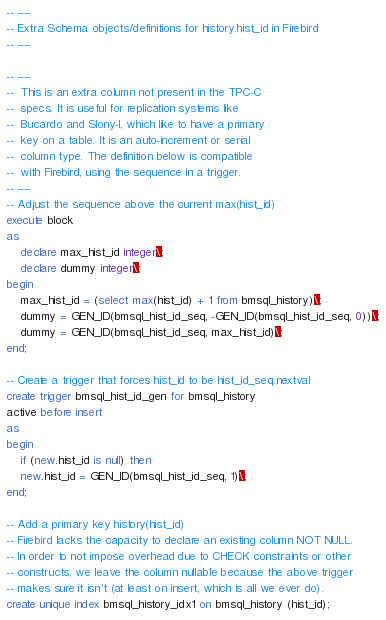Convert code to text. <code><loc_0><loc_0><loc_500><loc_500><_SQL_>-- ----
-- Extra Schema objects/definitions for history.hist_id in Firebird
-- ----

-- ----
--	This is an extra column not present in the TPC-C
--	specs. It is useful for replication systems like
--	Bucardo and Slony-I, which like to have a primary
--	key on a table. It is an auto-increment or serial
--	column type. The definition below is compatible
--	with Firebird, using the sequence in a trigger.
-- ----
-- Adjust the sequence above the current max(hist_id)
execute block 
as
    declare max_hist_id integer\;
    declare dummy integer\;
begin
    max_hist_id = (select max(hist_id) + 1 from bmsql_history)\;
    dummy = GEN_ID(bmsql_hist_id_seq, -GEN_ID(bmsql_hist_id_seq, 0))\;
    dummy = GEN_ID(bmsql_hist_id_seq, max_hist_id)\;
end;

-- Create a trigger that forces hist_id to be hist_id_seq.nextval
create trigger bmsql_hist_id_gen for bmsql_history
active before insert
as
begin
    if (new.hist_id is null) then
	new.hist_id = GEN_ID(bmsql_hist_id_seq, 1)\;
end;

-- Add a primary key history(hist_id)
-- Firebird lacks the capacity to declare an existing column NOT NULL.
-- In order to not impose overhead due to CHECK constraints or other
-- constructs, we leave the column nullable because the above trigger
-- makes sure it isn't (at least on insert, which is all we ever do).
create unique index bmsql_history_idx1 on bmsql_history (hist_id);
</code> 